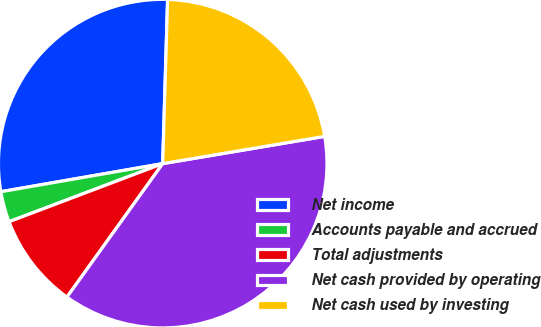<chart> <loc_0><loc_0><loc_500><loc_500><pie_chart><fcel>Net income<fcel>Accounts payable and accrued<fcel>Total adjustments<fcel>Net cash provided by operating<fcel>Net cash used by investing<nl><fcel>28.21%<fcel>3.02%<fcel>9.34%<fcel>37.56%<fcel>21.87%<nl></chart> 